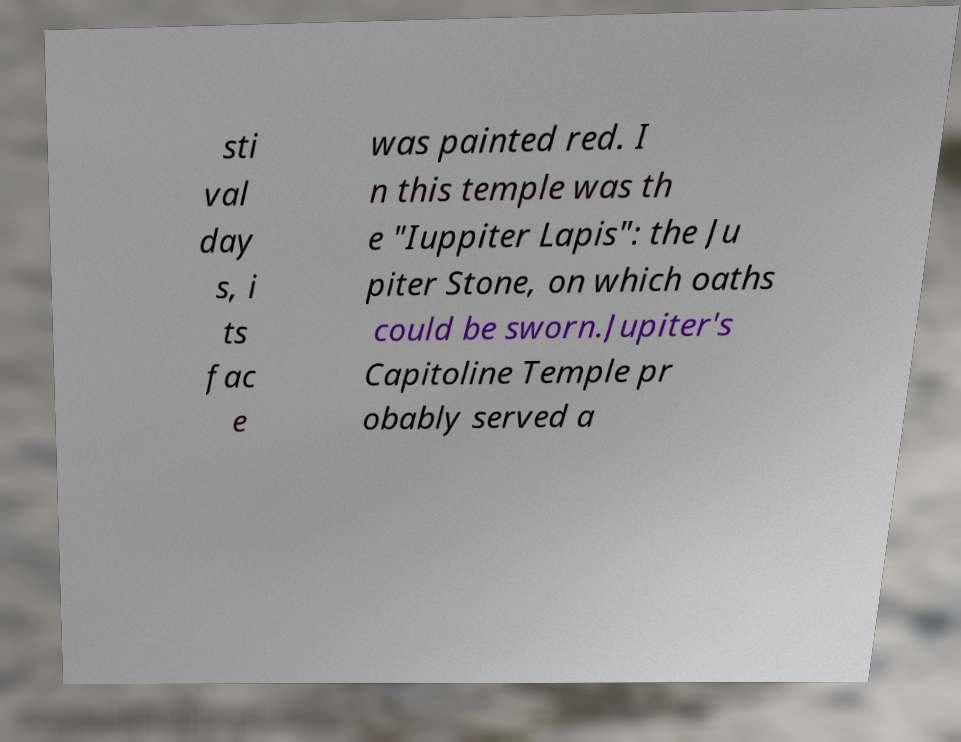For documentation purposes, I need the text within this image transcribed. Could you provide that? sti val day s, i ts fac e was painted red. I n this temple was th e "Iuppiter Lapis": the Ju piter Stone, on which oaths could be sworn.Jupiter's Capitoline Temple pr obably served a 